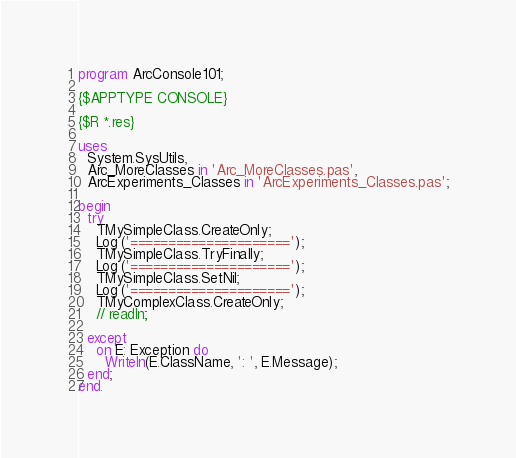<code> <loc_0><loc_0><loc_500><loc_500><_Pascal_>program ArcConsole101;

{$APPTYPE CONSOLE}

{$R *.res}

uses
  System.SysUtils,
  Arc_MoreClasses in 'Arc_MoreClasses.pas',
  ArcExperiments_Classes in 'ArcExperiments_Classes.pas';

begin
  try
    TMySimpleClass.CreateOnly;
    Log ('=====================');
    TMySimpleClass.TryFinally;
    Log ('=====================');
    TMySimpleClass.SetNil;
    Log ('=====================');
    TMyComplexClass.CreateOnly;
    // readln;

  except
    on E: Exception do
      Writeln(E.ClassName, ': ', E.Message);
  end;
end.


</code> 